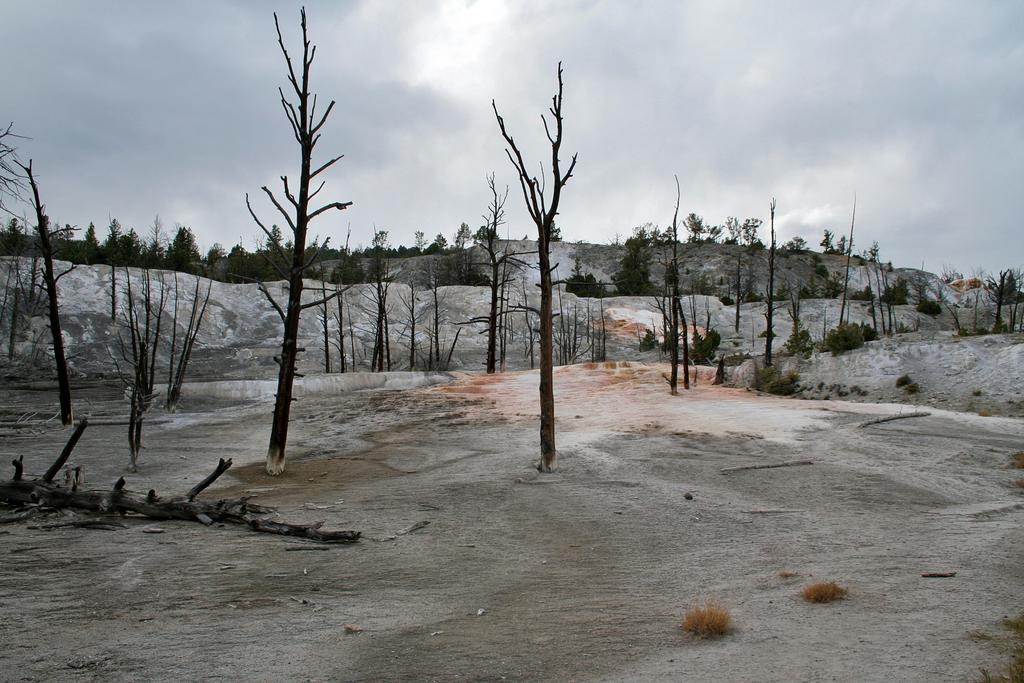What type of vegetation is present on the dry land in the image? There are dry trees on the dry land in the image. What can be seen in the background of the image? There are trees on the hills in the background. What is visible in the sky in the image? There are clouds in the sky. What type of hole can be seen in the image? There is no hole present in the image. Is there an airplane flying in the sky in the image? No, there is no airplane visible in the image. 